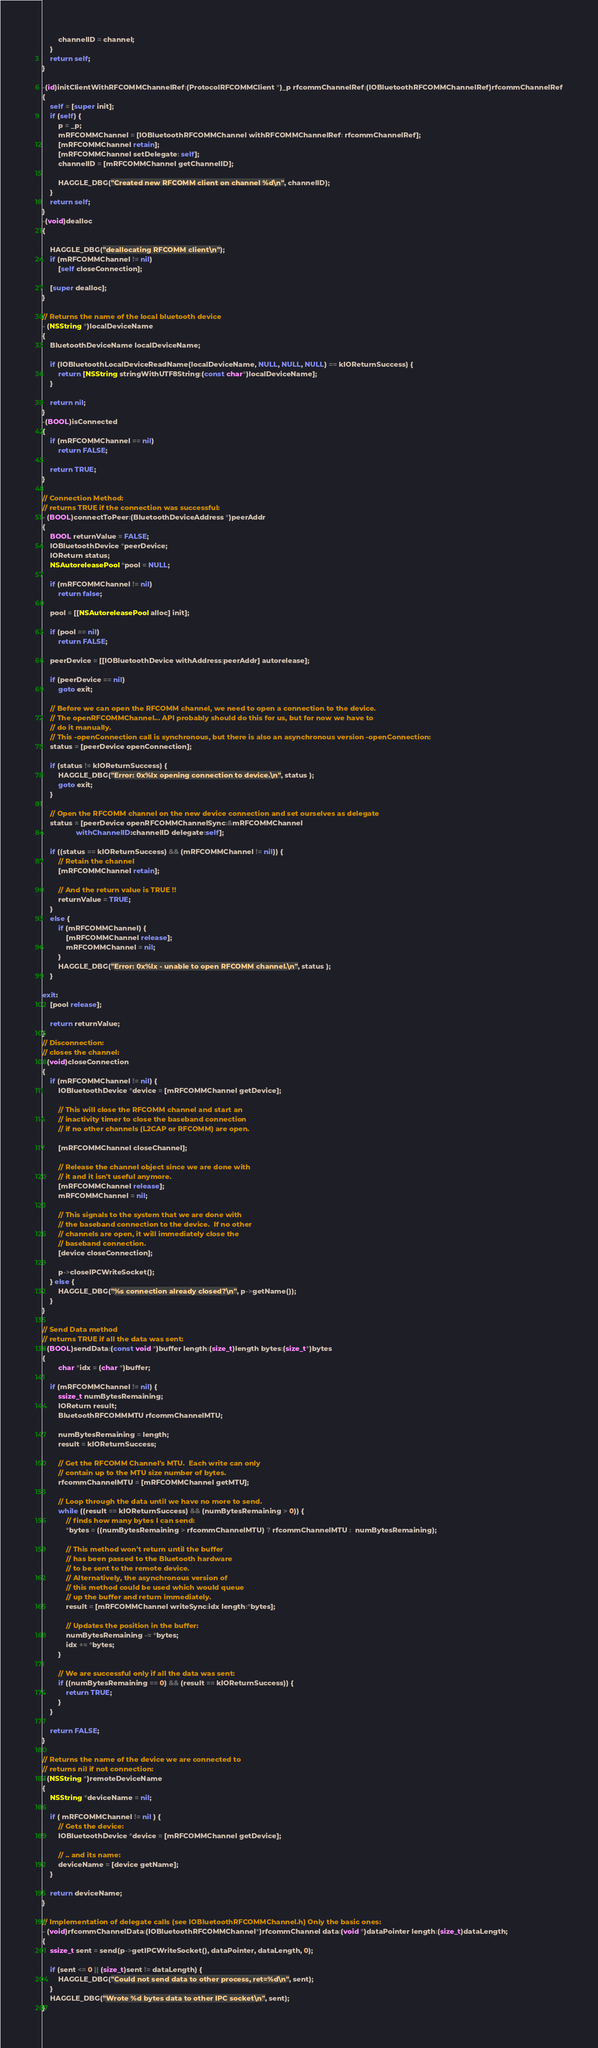<code> <loc_0><loc_0><loc_500><loc_500><_ObjectiveC_>		channelID = channel;
	}
	return self;
}

-(id)initClientWithRFCOMMChannelRef:(ProtocolRFCOMMClient *)_p rfcommChannelRef:(IOBluetoothRFCOMMChannelRef)rfcommChannelRef
{
	self = [super init];
	if (self) {
		p = _p;
		mRFCOMMChannel = [IOBluetoothRFCOMMChannel withRFCOMMChannelRef: rfcommChannelRef];
		[mRFCOMMChannel retain];
		[mRFCOMMChannel setDelegate: self];
		channelID = [mRFCOMMChannel getChannelID];
		
		HAGGLE_DBG("Created new RFCOMM client on channel %d\n", channelID);
	}
	return self;
}
-(void)dealloc
{
	
	HAGGLE_DBG("deallocating RFCOMM client\n");
	if (mRFCOMMChannel != nil)
		[self closeConnection];

	[super dealloc];
}

// Returns the name of the local bluetooth device
- (NSString *)localDeviceName
{
    BluetoothDeviceName localDeviceName;

    if (IOBluetoothLocalDeviceReadName(localDeviceName, NULL, NULL, NULL) == kIOReturnSuccess) {
        return [NSString stringWithUTF8String:(const char*)localDeviceName];
    }

    return nil;
}
-(BOOL)isConnected
{
	if (mRFCOMMChannel == nil)
		return FALSE;
	
	return TRUE;
}

// Connection Method:
// returns TRUE if the connection was successful:
- (BOOL)connectToPeer:(BluetoothDeviceAddress *)peerAddr
{
	BOOL returnValue = FALSE;
	IOBluetoothDevice *peerDevice;
	IOReturn status;
	NSAutoreleasePool *pool = NULL;
	
	if (mRFCOMMChannel != nil)
		return false;
	
	pool = [[NSAutoreleasePool alloc] init];
	
	if (pool == nil)
		return FALSE;

	peerDevice = [[IOBluetoothDevice withAddress:peerAddr] autorelease];

	if (peerDevice == nil)
		goto exit;
		
	// Before we can open the RFCOMM channel, we need to open a connection to the device.
	// The openRFCOMMChannel... API probably should do this for us, but for now we have to
	// do it manually.
	// This -openConnection call is synchronous, but there is also an asynchronous version -openConnection:
	status = [peerDevice openConnection];
	
	if (status != kIOReturnSuccess) {
		HAGGLE_DBG("Error: 0x%lx opening connection to device.\n", status );
		goto exit;
	}
	
	// Open the RFCOMM channel on the new device connection and set ourselves as delegate
	status = [peerDevice openRFCOMMChannelSync:&mRFCOMMChannel 
			     withChannelID:channelID delegate:self];
	
	if ((status == kIOReturnSuccess) && (mRFCOMMChannel != nil)) {
		// Retain the channel
		[mRFCOMMChannel retain];
		
		// And the return value is TRUE !!
		returnValue = TRUE;
	}
	else {
		if (mRFCOMMChannel) {
			[mRFCOMMChannel release];
			mRFCOMMChannel = nil;
		}
		HAGGLE_DBG("Error: 0x%lx - unable to open RFCOMM channel.\n", status );
	}
	
exit:
	[pool release];

	return returnValue;
}
// Disconnection:
// closes the channel:
- (void)closeConnection
{
	if (mRFCOMMChannel != nil) {
		IOBluetoothDevice *device = [mRFCOMMChannel getDevice];
		
		// This will close the RFCOMM channel and start an
		// inactivity timer to close the baseband connection
		// if no other channels (L2CAP or RFCOMM) are open.
		
		[mRFCOMMChannel closeChannel];
                
		// Release the channel object since we are done with
		// it and it isn't useful anymore.
		[mRFCOMMChannel release];
		mRFCOMMChannel = nil;
        
		// This signals to the system that we are done with
		// the baseband connection to the device.  If no other
		// channels are open, it will immediately close the
		// baseband connection.
		[device closeConnection];
		
		p->closeIPCWriteSocket();
	} else {
		HAGGLE_DBG("%s connection already closed?\n", p->getName());
	}
}

// Send Data method
// returns TRUE if all the data was sent:
- (BOOL)sendData:(const void *)buffer length:(size_t)length bytes:(size_t*)bytes
{
        char *idx = (char *)buffer;

	if (mRFCOMMChannel != nil) {
		ssize_t numBytesRemaining;
		IOReturn result;
		BluetoothRFCOMMMTU rfcommChannelMTU;
		
		numBytesRemaining = length;
		result = kIOReturnSuccess;
		
		// Get the RFCOMM Channel's MTU.  Each write can only
		// contain up to the MTU size number of bytes.
		rfcommChannelMTU = [mRFCOMMChannel getMTU];
		
		// Loop through the data until we have no more to send.
		while ((result == kIOReturnSuccess) && (numBytesRemaining > 0)) {
			// finds how many bytes I can send:
			*bytes = ((numBytesRemaining > rfcommChannelMTU) ? rfcommChannelMTU :  numBytesRemaining);
			
			// This method won't return until the buffer
			// has been passed to the Bluetooth hardware
			// to be sent to the remote device.
			// Alternatively, the asynchronous version of
			// this method could be used which would queue
			// up the buffer and return immediately.
			result = [mRFCOMMChannel writeSync:idx length:*bytes];
			
			// Updates the position in the buffer:
			numBytesRemaining -= *bytes;
			idx += *bytes;
		}
		
		// We are successful only if all the data was sent:
		if ((numBytesRemaining == 0) && (result == kIOReturnSuccess)) {
			return TRUE;
		}
	}
	
	return FALSE;
}

// Returns the name of the device we are connected to
// returns nil if not connection:
- (NSString *)remoteDeviceName
{
	NSString *deviceName = nil;
	
	if ( mRFCOMMChannel != nil ) {
		// Gets the device:
		IOBluetoothDevice *device = [mRFCOMMChannel getDevice];
		
		// .. and its name:
		deviceName = [device getName];
	}
	
	return deviceName;
}

// Implementation of delegate calls (see IOBluetoothRFCOMMChannel.h) Only the basic ones:
- (void)rfcommChannelData:(IOBluetoothRFCOMMChannel*)rfcommChannel data:(void *)dataPointer length:(size_t)dataLength;
{
	ssize_t sent = send(p->getIPCWriteSocket(), dataPointer, dataLength, 0);
	
	if (sent <= 0 || (size_t)sent != dataLength) {
		HAGGLE_DBG("Could not send data to other process, ret=%d\n", sent);
	}
	HAGGLE_DBG("Wrote %d bytes data to other IPC socket\n", sent);
}
</code> 